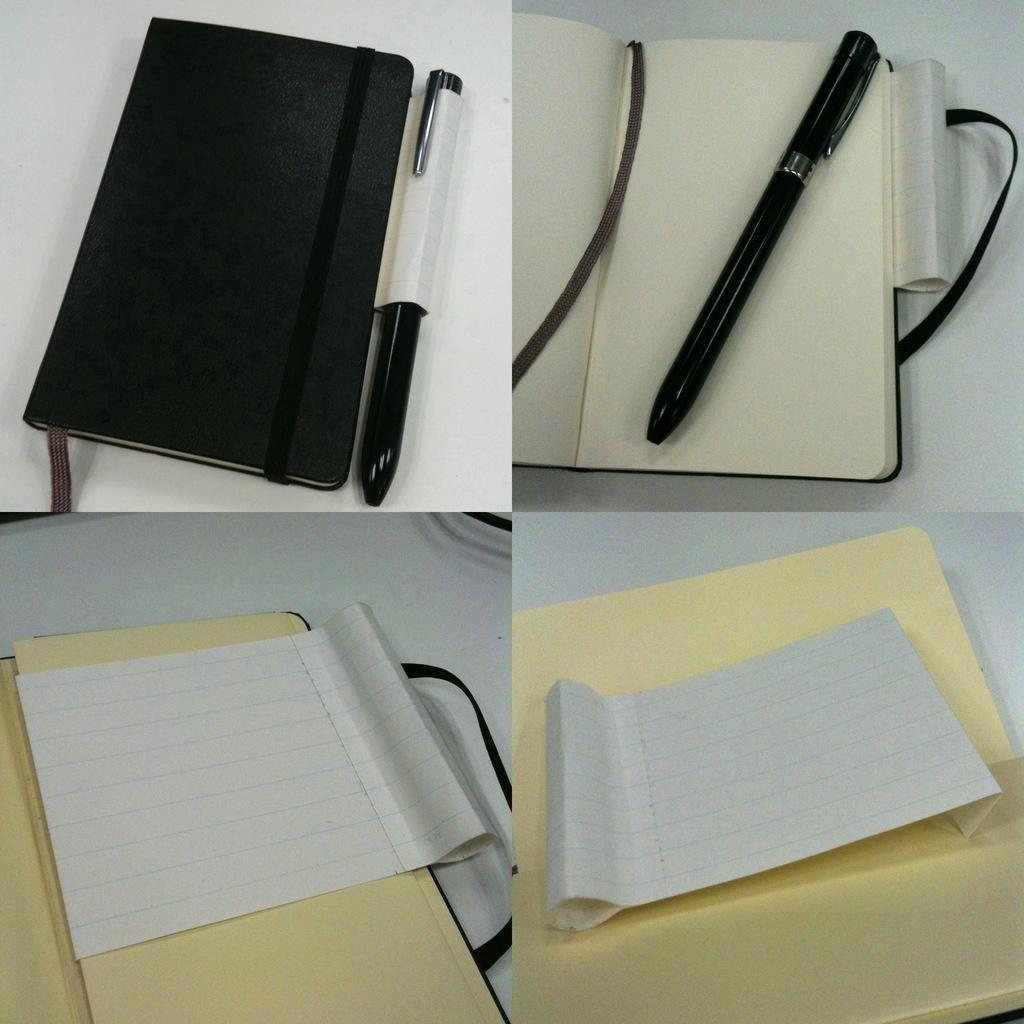What stationery item is visible in the image? There is a pen in the image. What is the pen used for in the image? The pen is likely used for writing in the diary, which is also visible in the image. Where are the pen and diary located in the image? The pen and diary are at the top side of the image. What other items can be seen in the image? There is a file and a paper on the file, which are located at the bottom side of the image. What type of noise can be heard coming from the sofa in the image? There is no sofa present in the image, so it is not possible to determine what, if any, noise might be heard. 